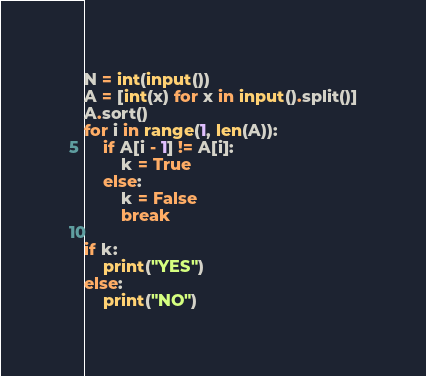<code> <loc_0><loc_0><loc_500><loc_500><_Python_>N = int(input())
A = [int(x) for x in input().split()]
A.sort()
for i in range(1, len(A)):
    if A[i - 1] != A[i]:
        k = True
    else:
        k = False
        break

if k:
    print("YES")
else:
    print("NO")</code> 